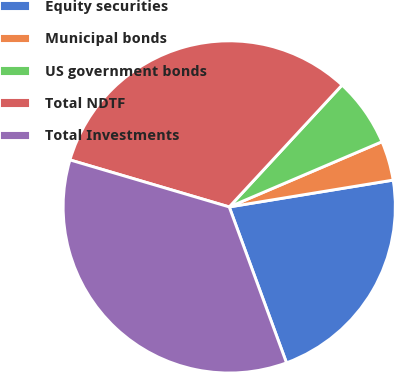<chart> <loc_0><loc_0><loc_500><loc_500><pie_chart><fcel>Equity securities<fcel>Municipal bonds<fcel>US government bonds<fcel>Total NDTF<fcel>Total Investments<nl><fcel>21.98%<fcel>3.84%<fcel>6.69%<fcel>32.32%<fcel>35.17%<nl></chart> 